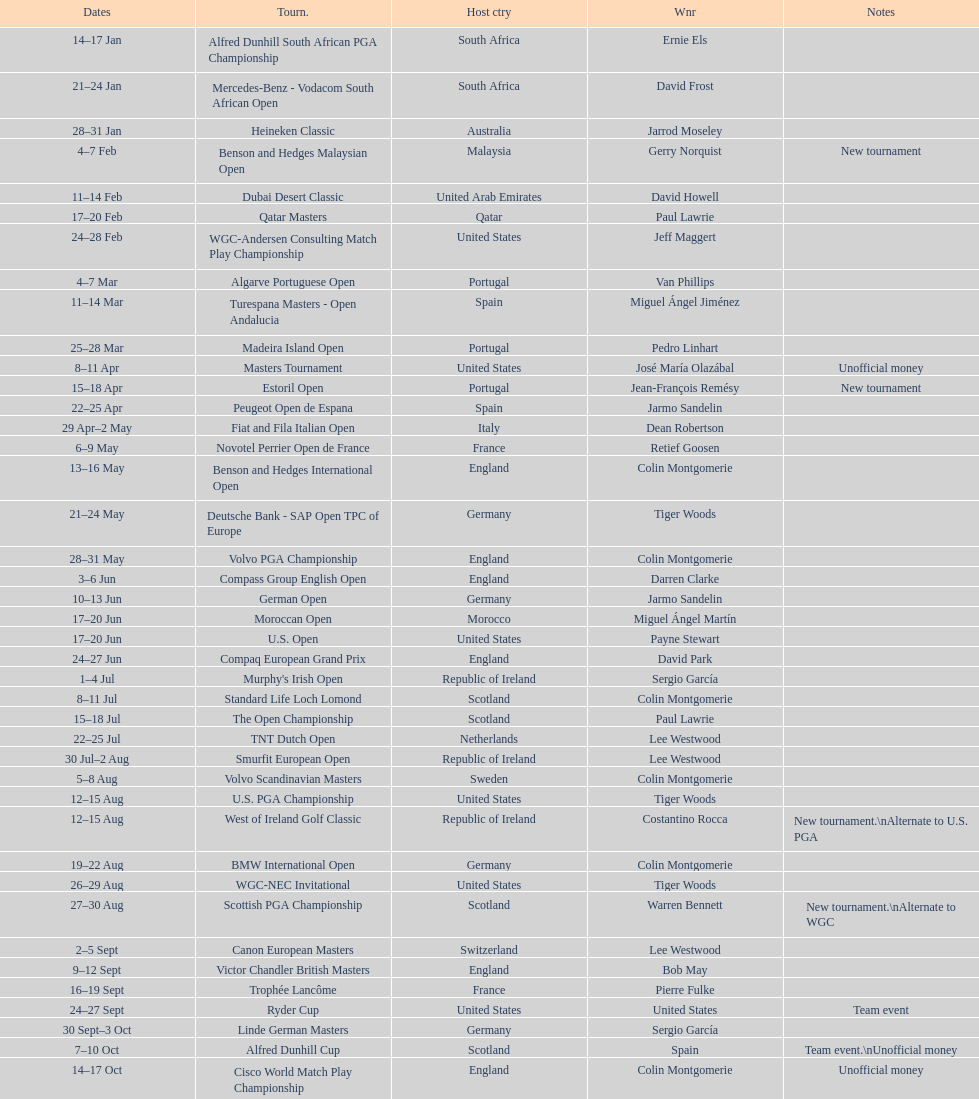How long did the estoril open last? 3 days. 